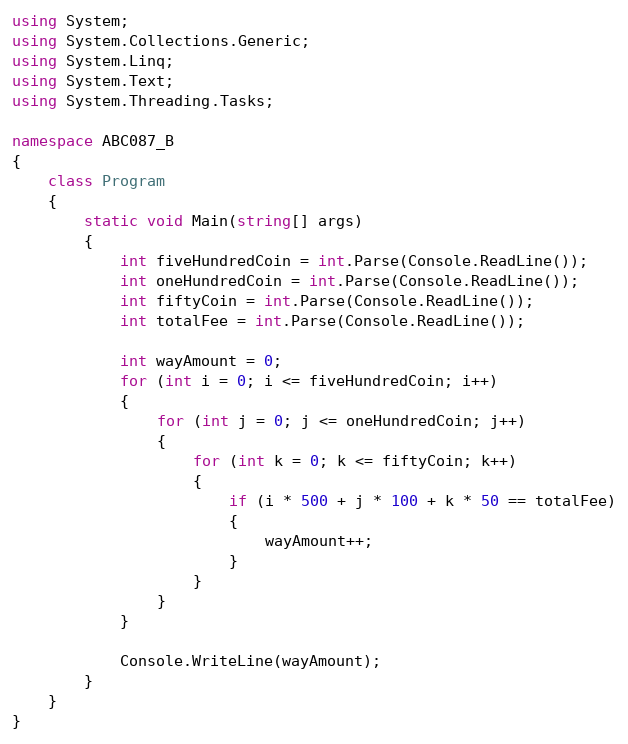Convert code to text. <code><loc_0><loc_0><loc_500><loc_500><_C#_>using System;
using System.Collections.Generic;
using System.Linq;
using System.Text;
using System.Threading.Tasks;

namespace ABC087_B
{
    class Program
    {
        static void Main(string[] args)
        {
            int fiveHundredCoin = int.Parse(Console.ReadLine());
            int oneHundredCoin = int.Parse(Console.ReadLine());
            int fiftyCoin = int.Parse(Console.ReadLine());
            int totalFee = int.Parse(Console.ReadLine());

            int wayAmount = 0;
            for (int i = 0; i <= fiveHundredCoin; i++)
            {
                for (int j = 0; j <= oneHundredCoin; j++)
                {
                    for (int k = 0; k <= fiftyCoin; k++)
                    {
                        if (i * 500 + j * 100 + k * 50 == totalFee)
                        {
                            wayAmount++;
                        }
                    }
                }
            }

            Console.WriteLine(wayAmount);
        }
    }
}
</code> 